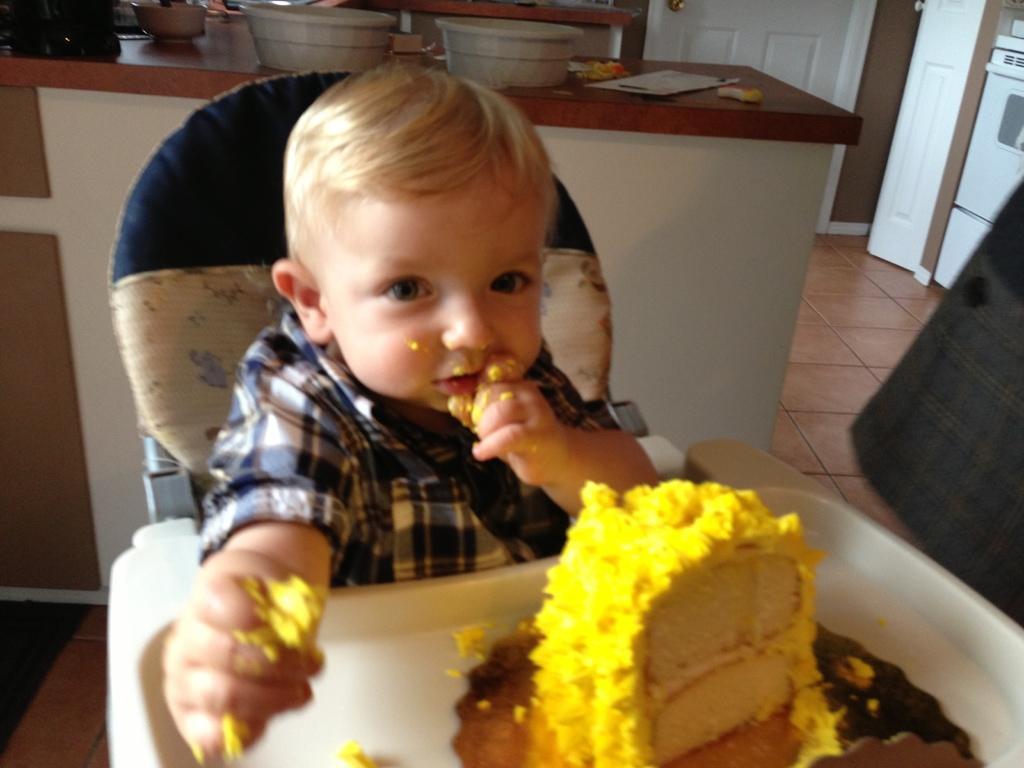Can you describe this image briefly? In this picture I can see a baby in blue shirt sitting on a chair and I can also see a cake in a plate. I can see baby's one hand is near the cake and another one is near his mouth. In the background I can see a counter top and two containers on it and also I can see door. 